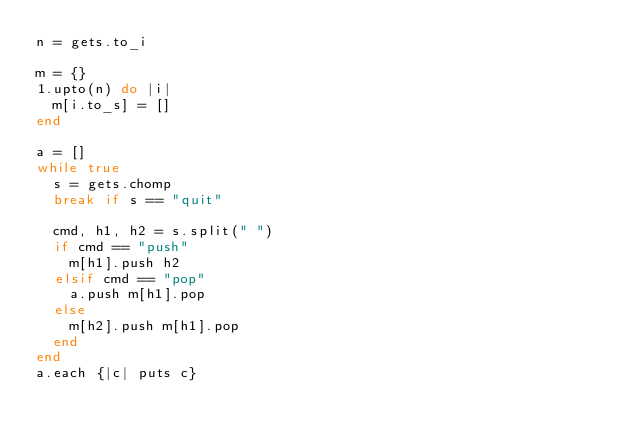<code> <loc_0><loc_0><loc_500><loc_500><_Ruby_>n = gets.to_i

m = {}
1.upto(n) do |i|
  m[i.to_s] = []
end

a = []
while true
  s = gets.chomp
  break if s == "quit"

  cmd, h1, h2 = s.split(" ")
  if cmd == "push"
    m[h1].push h2
  elsif cmd == "pop"
    a.push m[h1].pop
  else
    m[h2].push m[h1].pop
  end
end
a.each {|c| puts c}</code> 